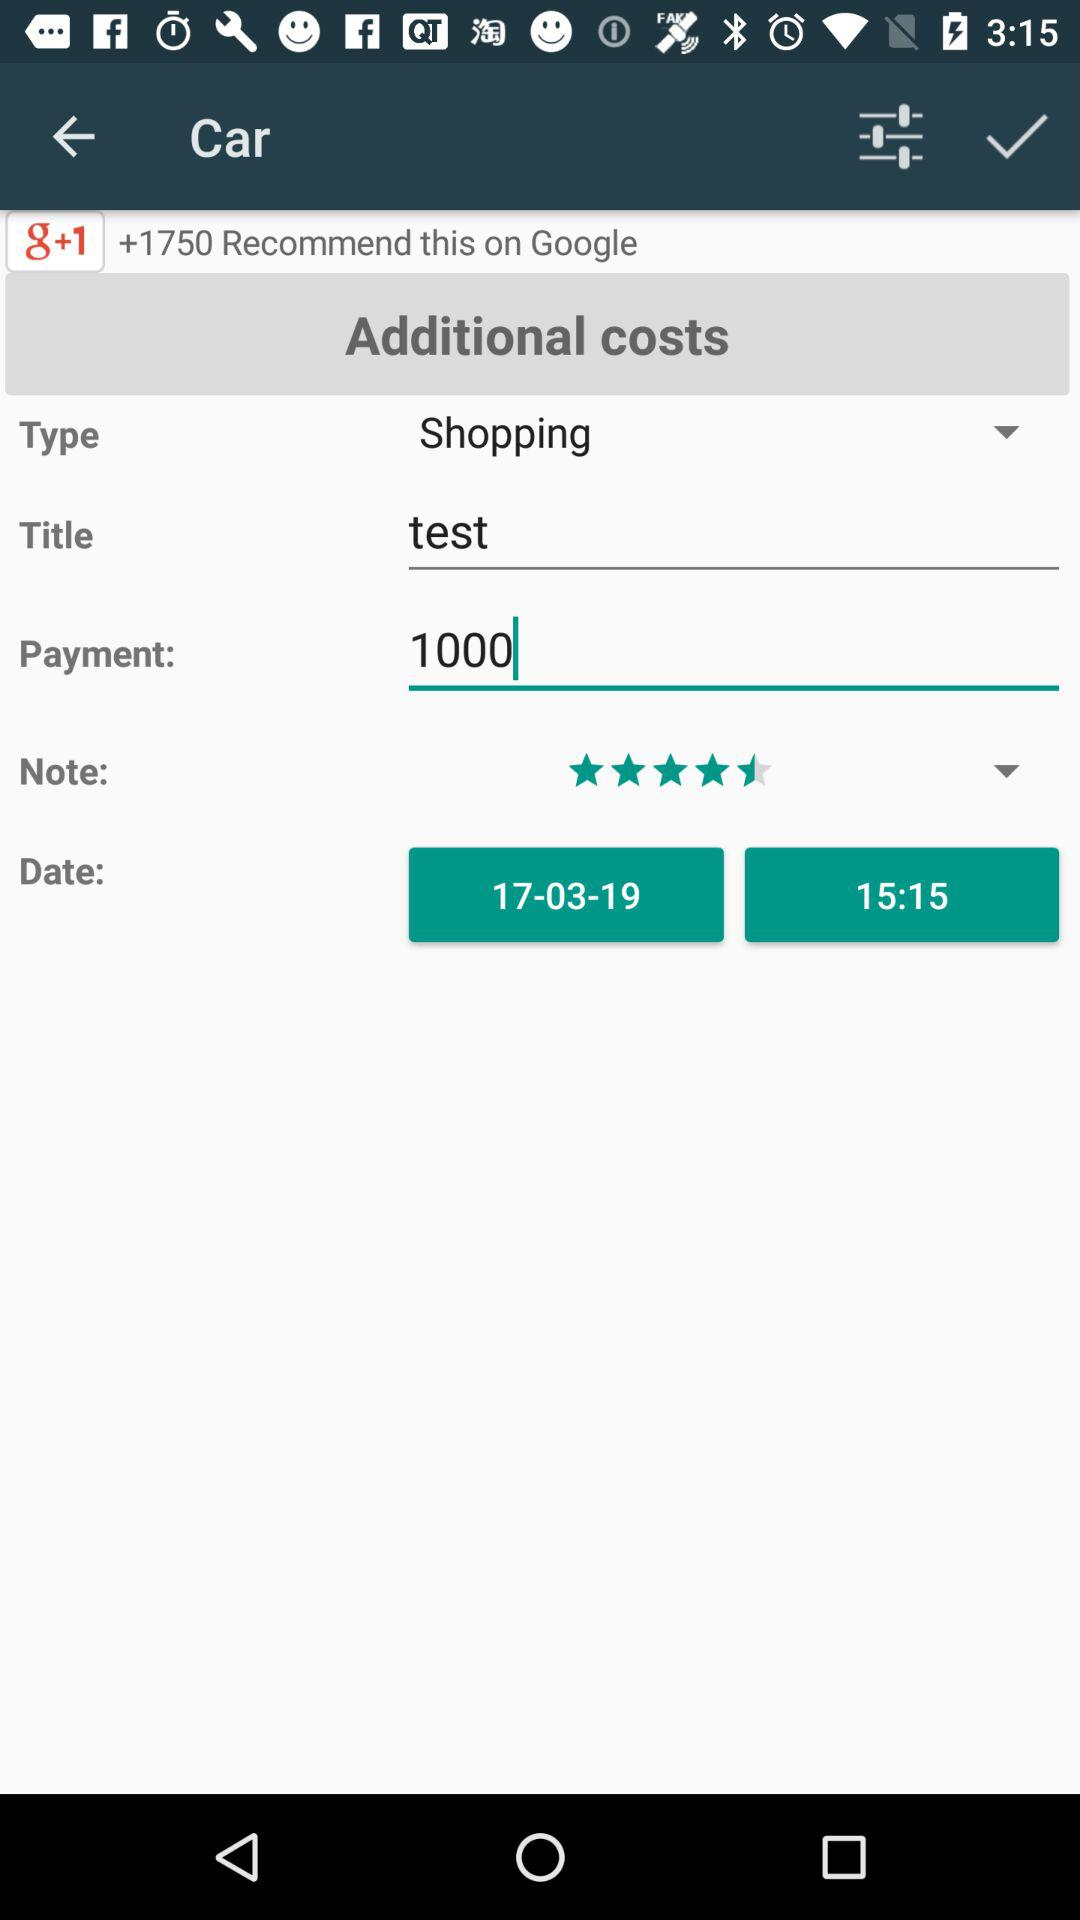How many people have recommended "g+1" on "Google"? There are +1750 people who have recommended "g+1" on "Google". 